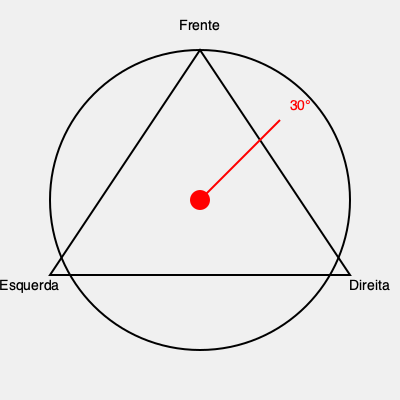Um palco triangular giratório está sendo projetado para um show de um artista emergente. O palco pode girar 360° para maximizar a visibilidade do público. Se o artista começa de frente para o público e o palco gira 30° no sentido horário, qual seção do público terá a melhor visão do artista após a rotação? Para resolver esta questão, devemos seguir estes passos:

1. Entender a configuração inicial:
   - O palco é triangular, com três seções de público: Frente, Direita e Esquerda.
   - O artista começa voltado para a seção "Frente".

2. Analisar a rotação:
   - O palco gira 30° no sentido horário.
   - Isso significa que o artista se move 30° em direção à seção "Direita".

3. Calcular a nova posição:
   - Como o triângulo é equilátero (assume-se pela simetria do diagrama), cada lado corresponde a 120°.
   - Uma rotação de 30° é apenas 1/4 do caminho para a próxima seção (30° / 120° = 1/4).

4. Determinar a melhor visibilidade:
   - Após a rotação, o artista estará mais próximo da seção "Frente" do que da "Direita".
   - A seção "Frente" ainda terá a melhor visão, embora ligeiramente deslocada.

5. Conclusão:
   - A seção "Frente" continuará tendo a melhor visão do artista após a rotação de 30°.
Answer: Frente 